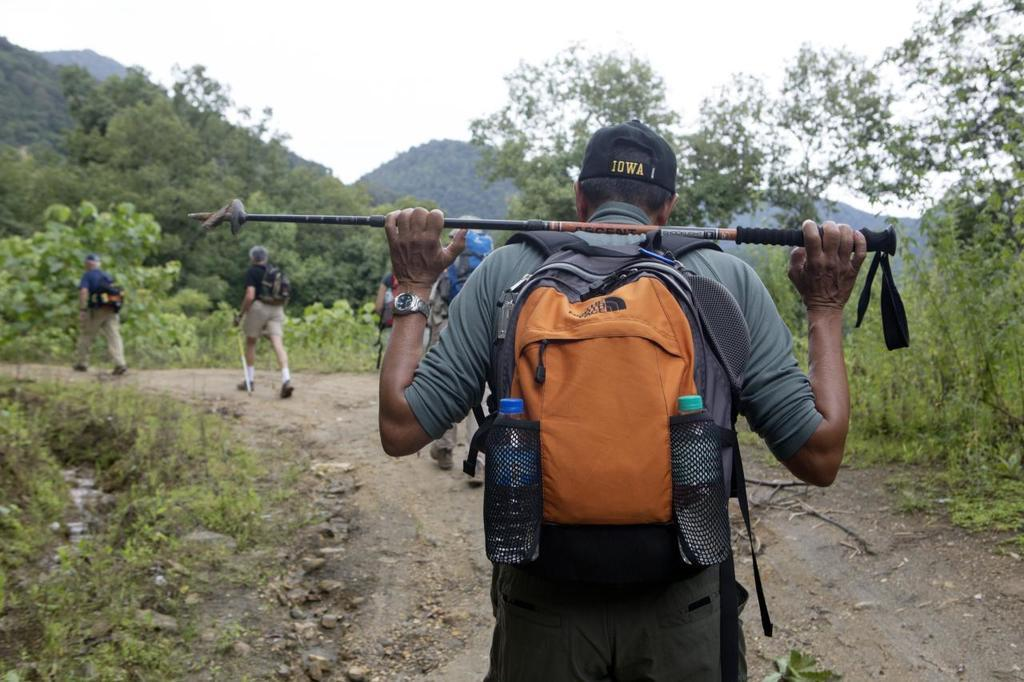<image>
Share a concise interpretation of the image provided. A man in an Iowa cap with an orange The North Face backpack hikes down a trail. 